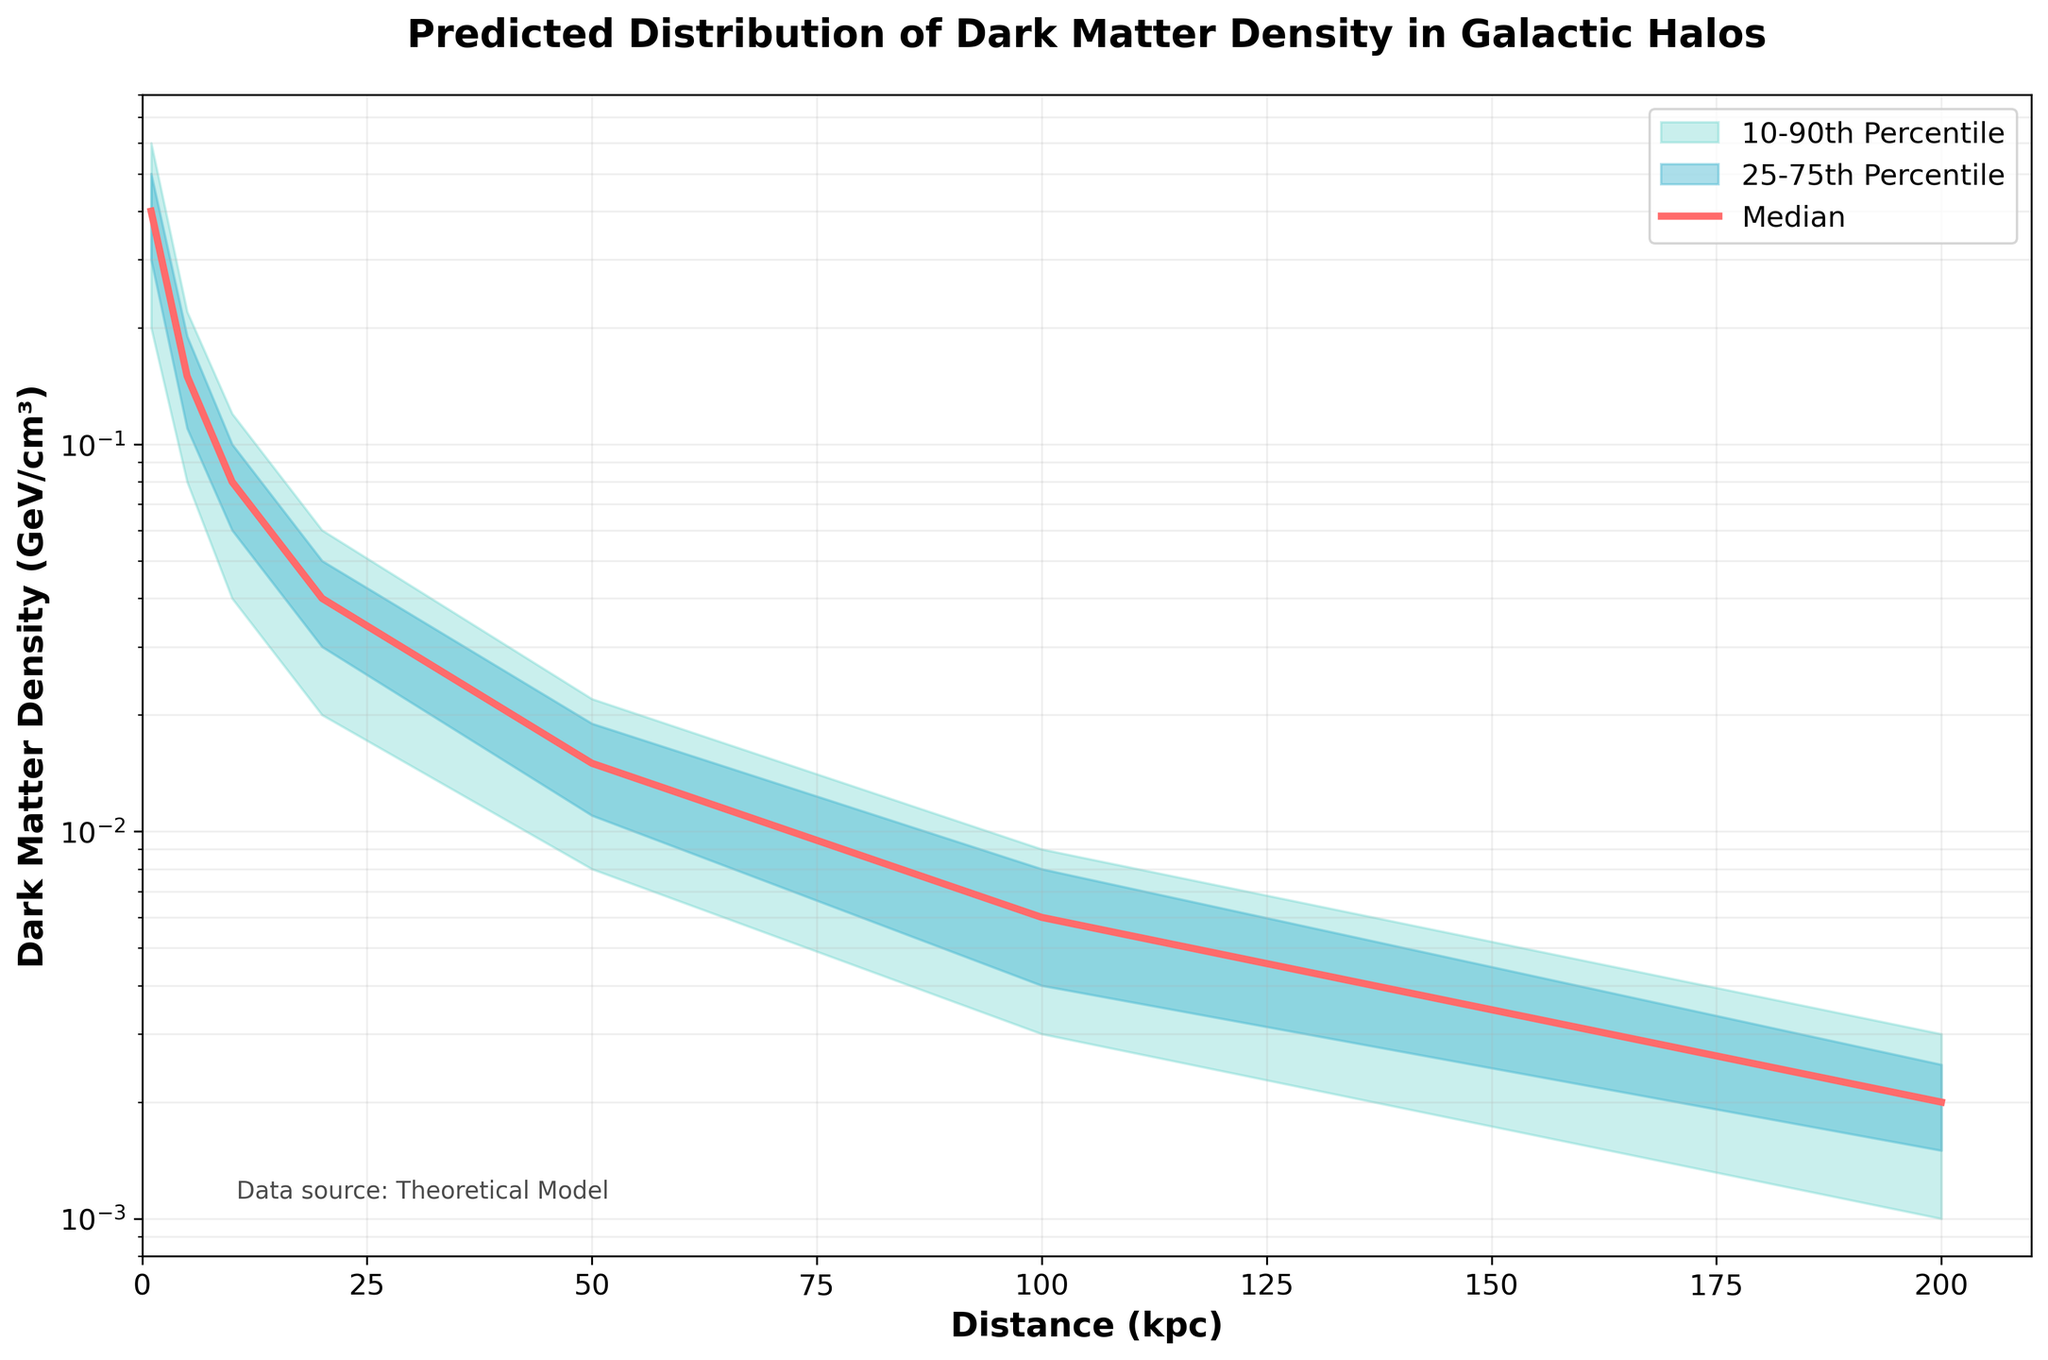What is the title of the chart? The title is located at the top of the chart and provides an overview of the content. The title is "Predicted Distribution of Dark Matter Density in Galactic Halos".
Answer: Predicted Distribution of Dark Matter Density in Galactic Halos What are the x-axis and y-axis labels? The x-axis label indicates the horizontal axis representing the distance in kiloparsecs (kpc). The y-axis label indicates the vertical axis representing the dark matter density in GeV/cm³.
Answer: Distance (kpc) and Dark Matter Density (GeV/cm³) What does the median line represent in this chart? The median line, shown in a specific color, represents the median dark matter density values at different distances from the center of the galactic halo.
Answer: The median dark matter density How many different percentiles are visually represented, and what are they? The chart shows fill-between regions for three ranges of percentiles: 10th-90th, 25th-75th, and the median line itself, making three visual percentile ranges.
Answer: Three (10th-90th, 25th-75th, and median) What is the median dark matter density at a distance of 50 kpc? The median value at 50 kpc can be read off directly from the median line on the chart, which corresponds to approximately 0.015 GeV/cm³ according to the provided data.
Answer: 0.015 GeV/cm³ How does the dark matter density change as the distance increases from 1 kpc to 200 kpc? As seen from the chart, the median dark matter density decreases logarithmically from its highest density at 1 kpc to a much lower density at 200 kpc. This indicates an inverse relationship between distance and dark matter density.
Answer: Decreases logarithmically At what distance does the dark matter density first drop below 0.01 GeV/cm³ in the median line? By examining the median line, it becomes clear that the dark matter density drops below 0.01 GeV/cm³ between the distances of 50 kpc and 100 kpc. The exact value from the data is 50 kpc.
Answer: 50 kpc Describe the uncertainty in dark matter density at a distance of 5 kpc. Uncertainty can be seen through the spread between the 10th-90th percentile and the 25th-75th percentile areas. At 5 kpc, the 10th-90th percentile range varies between 0.08 and 0.22 GeV/cm³, indicating moderate uncertainty.
Answer: Moderate uncertainty According to the chart, what is the maximum predicted dark matter density at 1 kpc, based on the 90th percentile? The chart indicates that the 90th percentile value at 1 kpc represents the maximum predicted density at this distance, which is approximately 0.6 GeV/cm³ based on the data.
Answer: 0.6 GeV/cm³ 